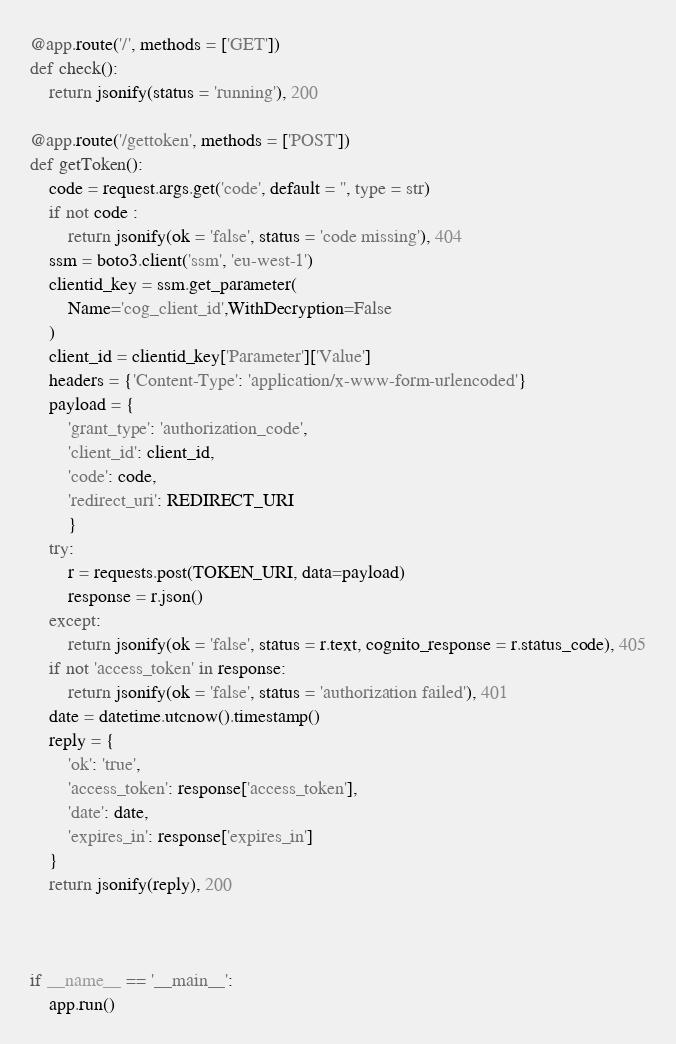Convert code to text. <code><loc_0><loc_0><loc_500><loc_500><_Python_>@app.route('/', methods = ['GET'])
def check():
    return jsonify(status = 'running'), 200

@app.route('/gettoken', methods = ['POST'])
def getToken():
    code = request.args.get('code', default = '', type = str)
    if not code :
        return jsonify(ok = 'false', status = 'code missing'), 404
    ssm = boto3.client('ssm', 'eu-west-1')
    clientid_key = ssm.get_parameter(
        Name='cog_client_id',WithDecryption=False
    )
    client_id = clientid_key['Parameter']['Value']
    headers = {'Content-Type': 'application/x-www-form-urlencoded'}
    payload = {
        'grant_type': 'authorization_code',
        'client_id': client_id,
        'code': code,
        'redirect_uri': REDIRECT_URI
        }
    try:
        r = requests.post(TOKEN_URI, data=payload)
        response = r.json()
    except:
        return jsonify(ok = 'false', status = r.text, cognito_response = r.status_code), 405
    if not 'access_token' in response:
        return jsonify(ok = 'false', status = 'authorization failed'), 401
    date = datetime.utcnow().timestamp()
    reply = {
        'ok': 'true',
        'access_token': response['access_token'],
        'date': date,
        'expires_in': response['expires_in']
    }
    return jsonify(reply), 200



if __name__ == '__main__':
    app.run()
</code> 